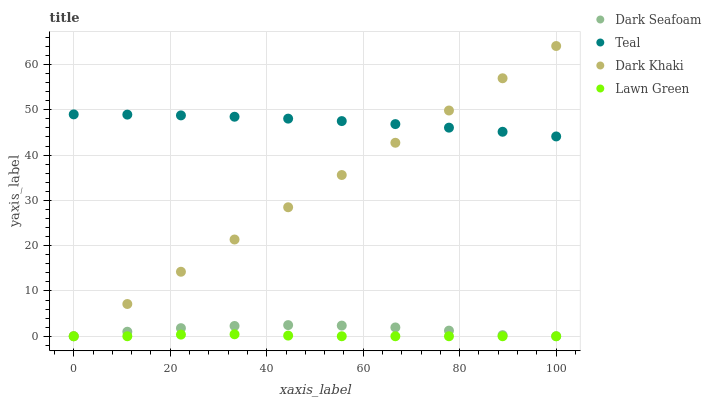Does Lawn Green have the minimum area under the curve?
Answer yes or no. Yes. Does Teal have the maximum area under the curve?
Answer yes or no. Yes. Does Dark Seafoam have the minimum area under the curve?
Answer yes or no. No. Does Dark Seafoam have the maximum area under the curve?
Answer yes or no. No. Is Dark Khaki the smoothest?
Answer yes or no. Yes. Is Dark Seafoam the roughest?
Answer yes or no. Yes. Is Lawn Green the smoothest?
Answer yes or no. No. Is Lawn Green the roughest?
Answer yes or no. No. Does Dark Khaki have the lowest value?
Answer yes or no. Yes. Does Teal have the lowest value?
Answer yes or no. No. Does Dark Khaki have the highest value?
Answer yes or no. Yes. Does Dark Seafoam have the highest value?
Answer yes or no. No. Is Lawn Green less than Teal?
Answer yes or no. Yes. Is Teal greater than Dark Seafoam?
Answer yes or no. Yes. Does Teal intersect Dark Khaki?
Answer yes or no. Yes. Is Teal less than Dark Khaki?
Answer yes or no. No. Is Teal greater than Dark Khaki?
Answer yes or no. No. Does Lawn Green intersect Teal?
Answer yes or no. No. 